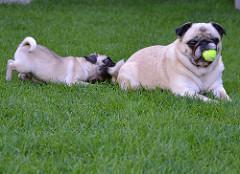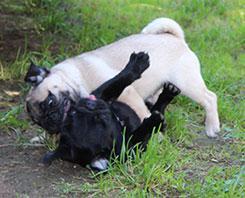The first image is the image on the left, the second image is the image on the right. Analyze the images presented: Is the assertion "There are two dogs." valid? Answer yes or no. No. The first image is the image on the left, the second image is the image on the right. Given the left and right images, does the statement "At least one of the dogs is playing with a ball that has spikes on it." hold true? Answer yes or no. No. 